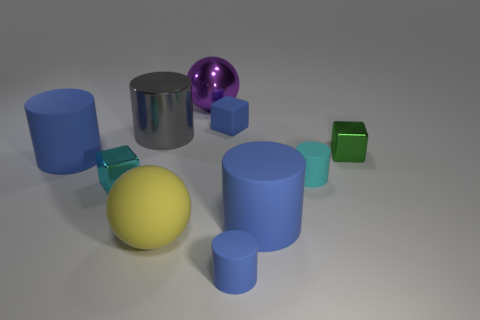Subtract all green spheres. How many blue cylinders are left? 3 Subtract all gray cylinders. How many cylinders are left? 4 Subtract all big gray metallic cylinders. How many cylinders are left? 4 Subtract 1 cylinders. How many cylinders are left? 4 Subtract all brown cylinders. Subtract all green balls. How many cylinders are left? 5 Subtract all cubes. How many objects are left? 7 Subtract all green blocks. Subtract all small blue objects. How many objects are left? 7 Add 1 cyan matte things. How many cyan matte things are left? 2 Add 6 metallic cylinders. How many metallic cylinders exist? 7 Subtract 1 cyan blocks. How many objects are left? 9 